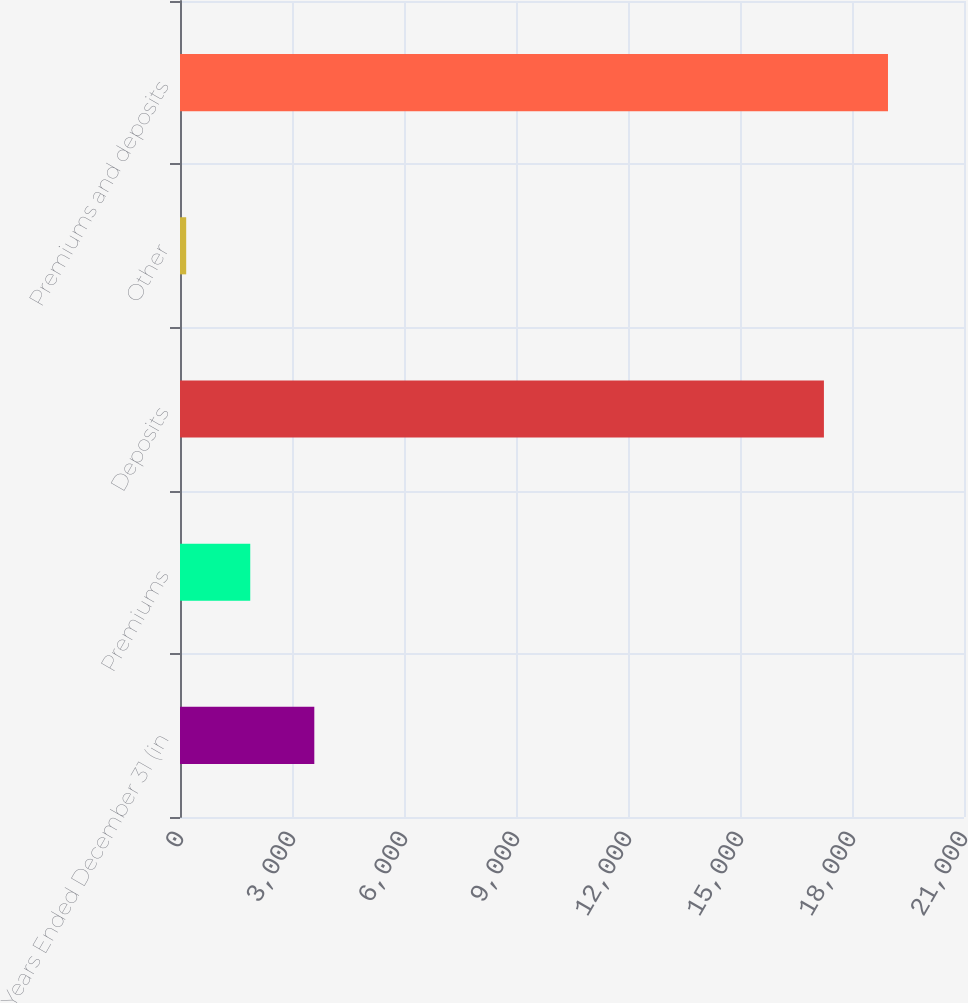Convert chart to OTSL. <chart><loc_0><loc_0><loc_500><loc_500><bar_chart><fcel>Years Ended December 31 (in<fcel>Premiums<fcel>Deposits<fcel>Other<fcel>Premiums and deposits<nl><fcel>3597.6<fcel>1881.8<fcel>17248<fcel>166<fcel>18963.8<nl></chart> 